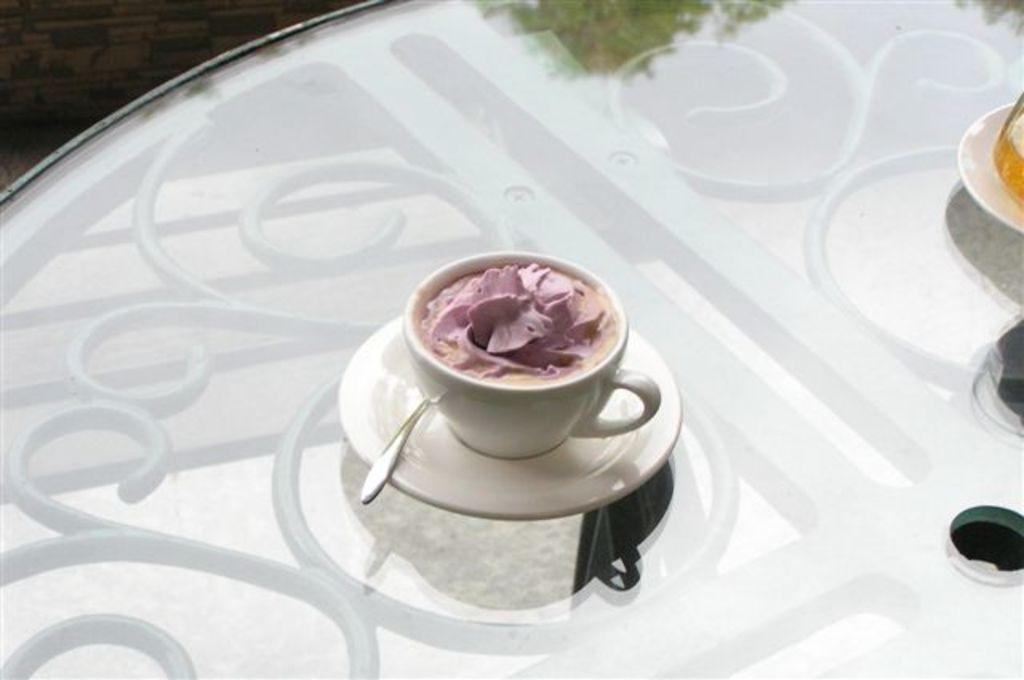What type of dessert is visible in the image? There is an ice cream in a cup in the image. Where is the ice cream located? The ice cream is on a table. Can you describe the table in the image? The table is the surface on which the ice cream is placed. How many horses are tied to the table in the image? There are no horses present in the image. 